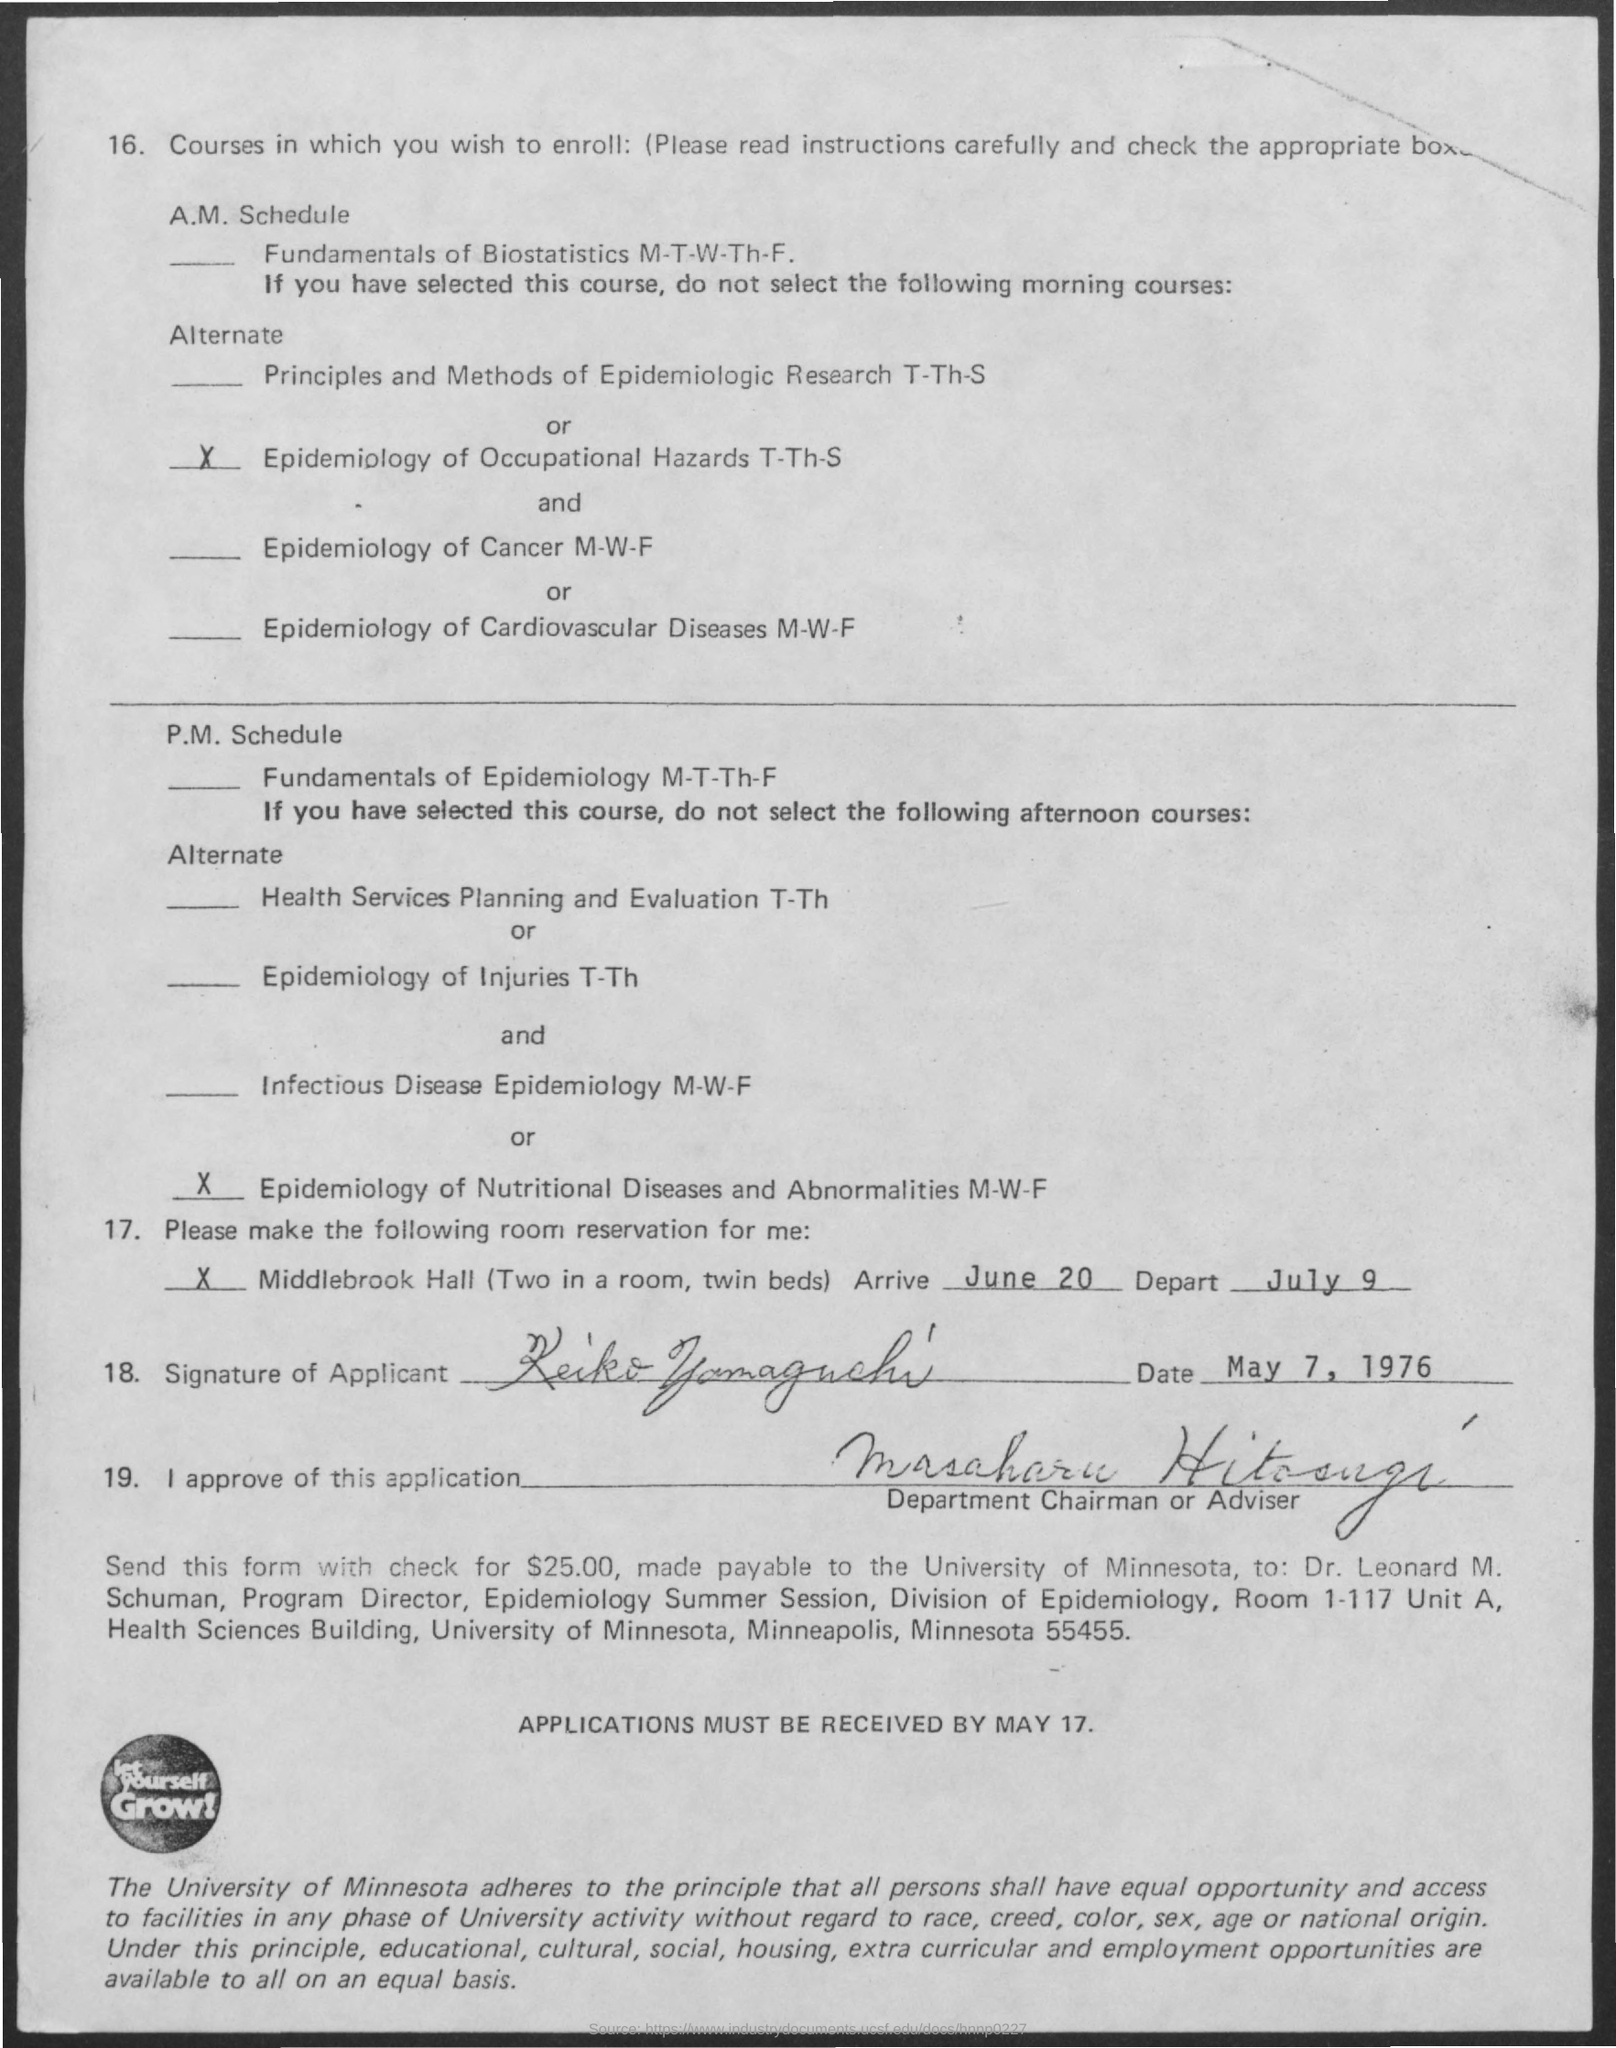What is written inside the circle at the bottom?
Your response must be concise. Let yourself Grow!. What is the arrival date?
Keep it short and to the point. June 20. What is the departing date?
Offer a terse response. July 9. What is the date in which the document is signed?
Make the answer very short. May 7, 1976. 